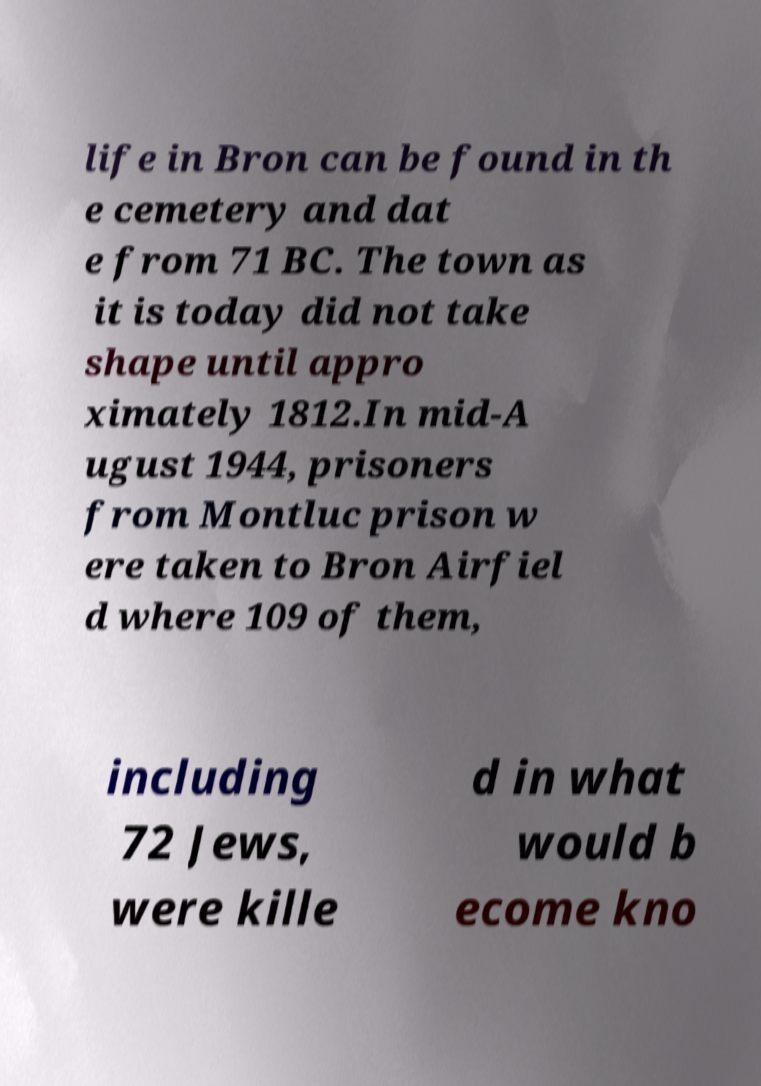What messages or text are displayed in this image? I need them in a readable, typed format. life in Bron can be found in th e cemetery and dat e from 71 BC. The town as it is today did not take shape until appro ximately 1812.In mid-A ugust 1944, prisoners from Montluc prison w ere taken to Bron Airfiel d where 109 of them, including 72 Jews, were kille d in what would b ecome kno 